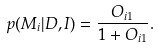Convert formula to latex. <formula><loc_0><loc_0><loc_500><loc_500>p ( M _ { i } | D , I ) = \frac { O _ { i 1 } } { 1 + O _ { i 1 } } .</formula> 